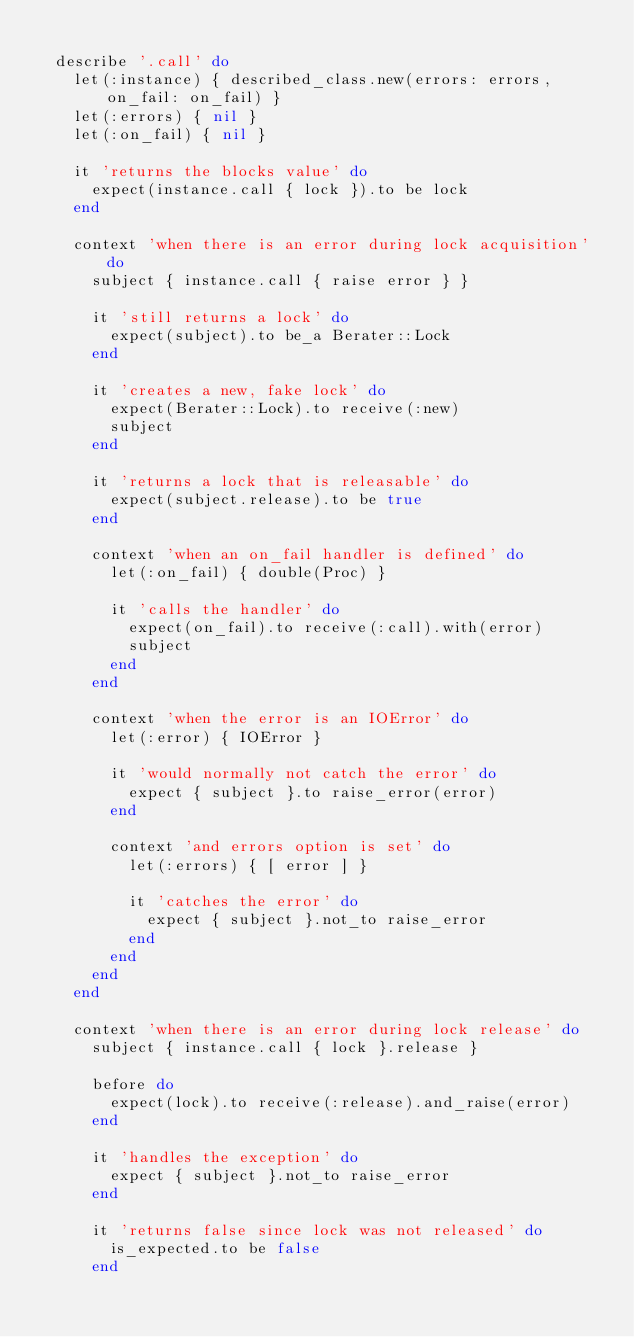<code> <loc_0><loc_0><loc_500><loc_500><_Ruby_>
  describe '.call' do
    let(:instance) { described_class.new(errors: errors, on_fail: on_fail) }
    let(:errors) { nil }
    let(:on_fail) { nil }

    it 'returns the blocks value' do
      expect(instance.call { lock }).to be lock
    end

    context 'when there is an error during lock acquisition' do
      subject { instance.call { raise error } }

      it 'still returns a lock' do
        expect(subject).to be_a Berater::Lock
      end

      it 'creates a new, fake lock' do
        expect(Berater::Lock).to receive(:new)
        subject
      end

      it 'returns a lock that is releasable' do
        expect(subject.release).to be true
      end

      context 'when an on_fail handler is defined' do
        let(:on_fail) { double(Proc) }

        it 'calls the handler' do
          expect(on_fail).to receive(:call).with(error)
          subject
        end
      end

      context 'when the error is an IOError' do
        let(:error) { IOError }

        it 'would normally not catch the error' do
          expect { subject }.to raise_error(error)
        end

        context 'and errors option is set' do
          let(:errors) { [ error ] }

          it 'catches the error' do
            expect { subject }.not_to raise_error
          end
        end
      end
    end

    context 'when there is an error during lock release' do
      subject { instance.call { lock }.release }

      before do
        expect(lock).to receive(:release).and_raise(error)
      end

      it 'handles the exception' do
        expect { subject }.not_to raise_error
      end

      it 'returns false since lock was not released' do
        is_expected.to be false
      end
</code> 